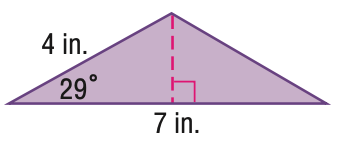Question: Find the area of the triangle. Round to the nearest hundredth.
Choices:
A. 3.88
B. 6.79
C. 13.58
D. 14
Answer with the letter. Answer: B 